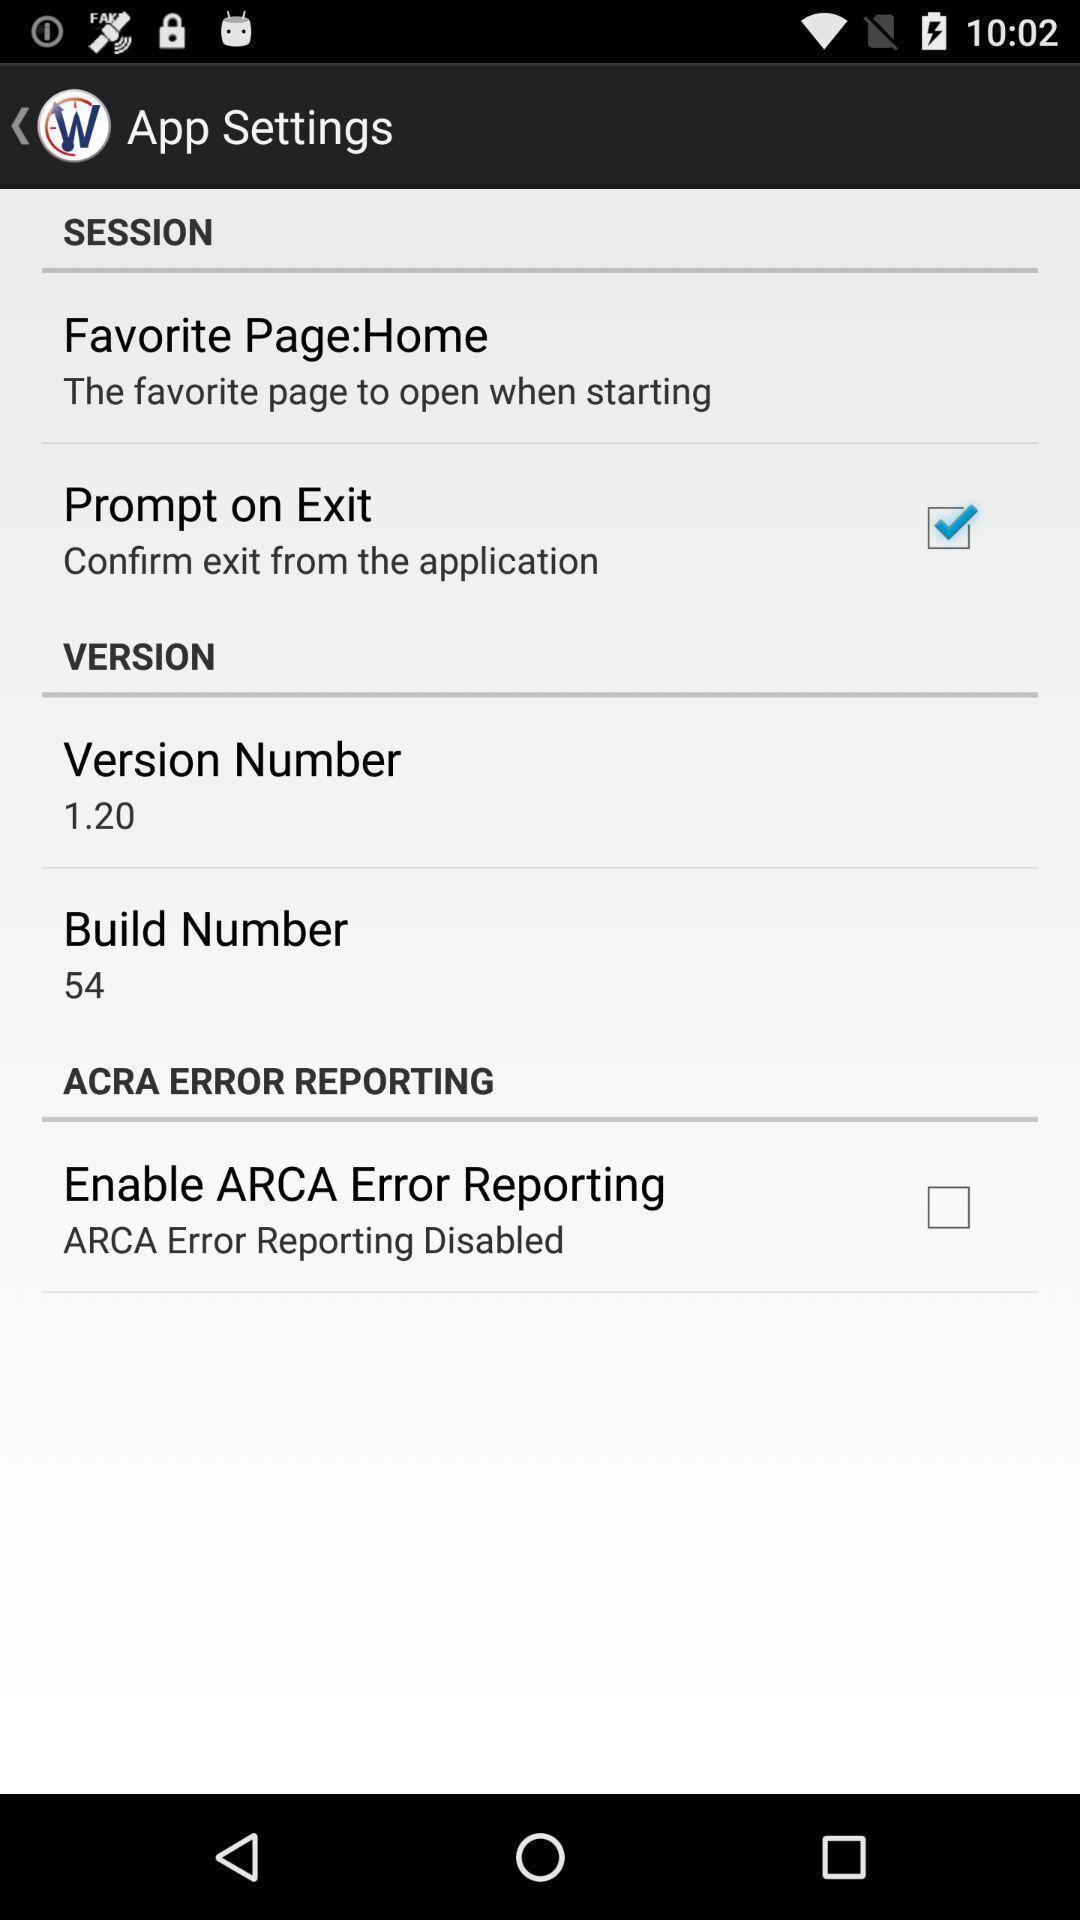Provide a description of this screenshot. Screen shows different app settings. 